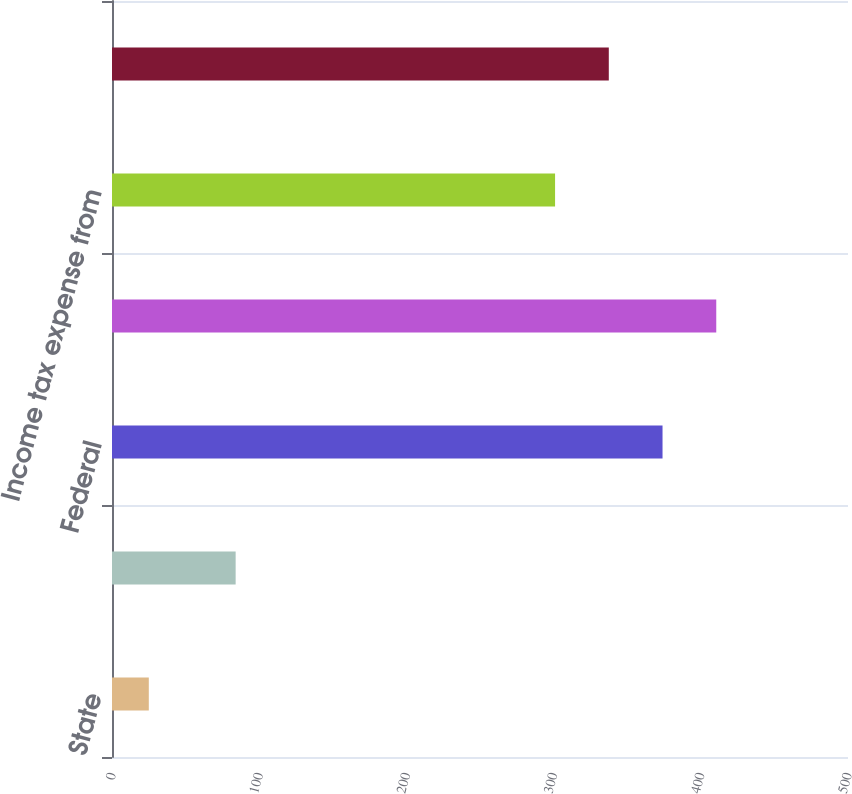<chart> <loc_0><loc_0><loc_500><loc_500><bar_chart><fcel>State<fcel>Total current income taxes<fcel>Federal<fcel>Total deferred income taxes<fcel>Income tax expense from<fcel>Statements of Operations<nl><fcel>25<fcel>84<fcel>374<fcel>410.5<fcel>301<fcel>337.5<nl></chart> 